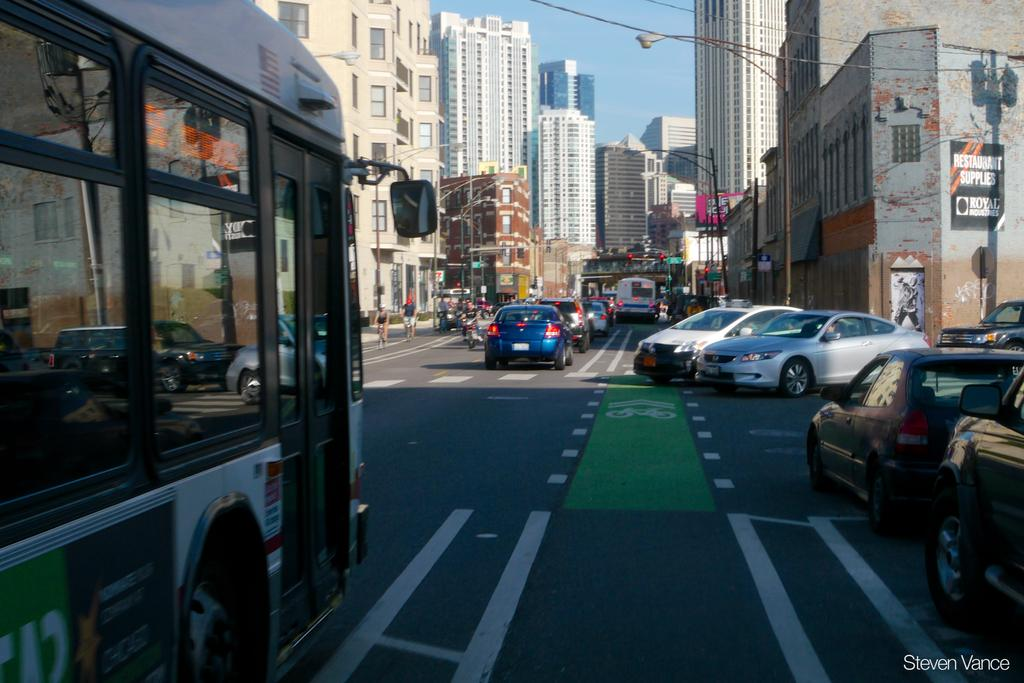What can be seen on the road in the image? There are vehicles and people on the road in the image. What is located on the right side of the road in the image? There is a street light on the right side of the road in the image. What can be seen in the background of the image? There are buildings visible in the background of the image. What type of appliance is being used by the people on the road in the image? There is no appliance being used by the people on the road in the image. How does the building on the left side of the road move in the image? There is no building on the left side of the road in the image, and buildings do not move. 